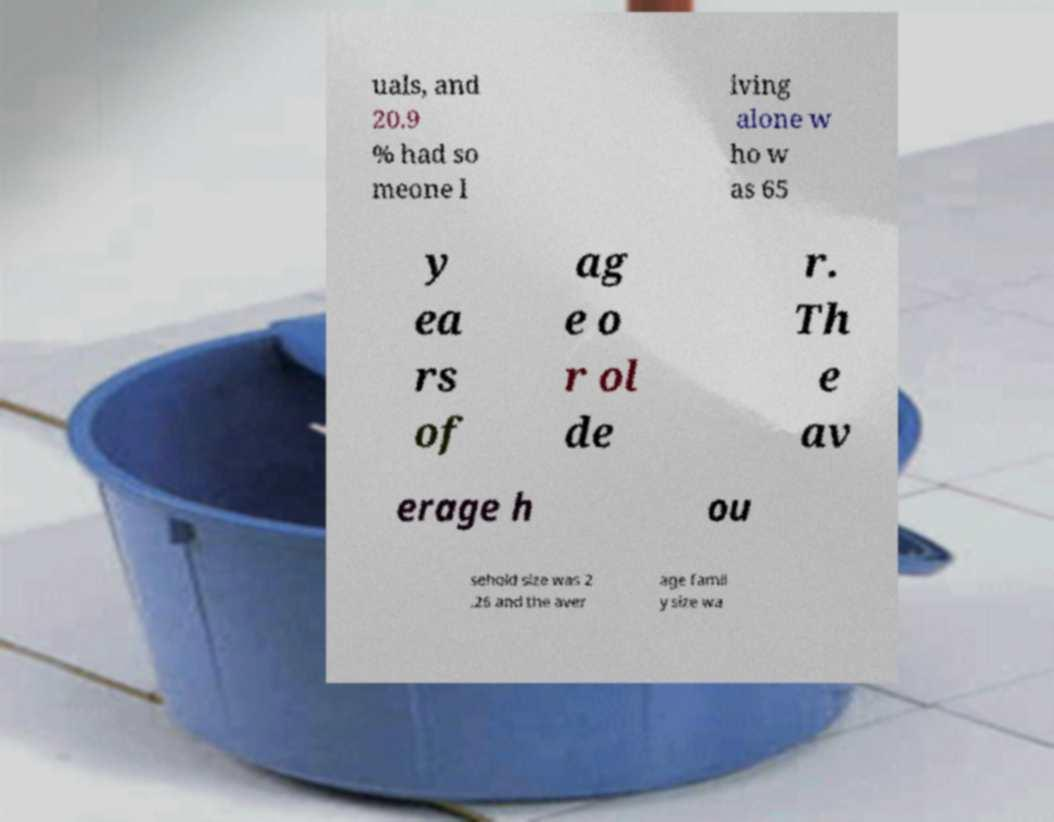Can you read and provide the text displayed in the image?This photo seems to have some interesting text. Can you extract and type it out for me? uals, and 20.9 % had so meone l iving alone w ho w as 65 y ea rs of ag e o r ol de r. Th e av erage h ou sehold size was 2 .26 and the aver age famil y size wa 